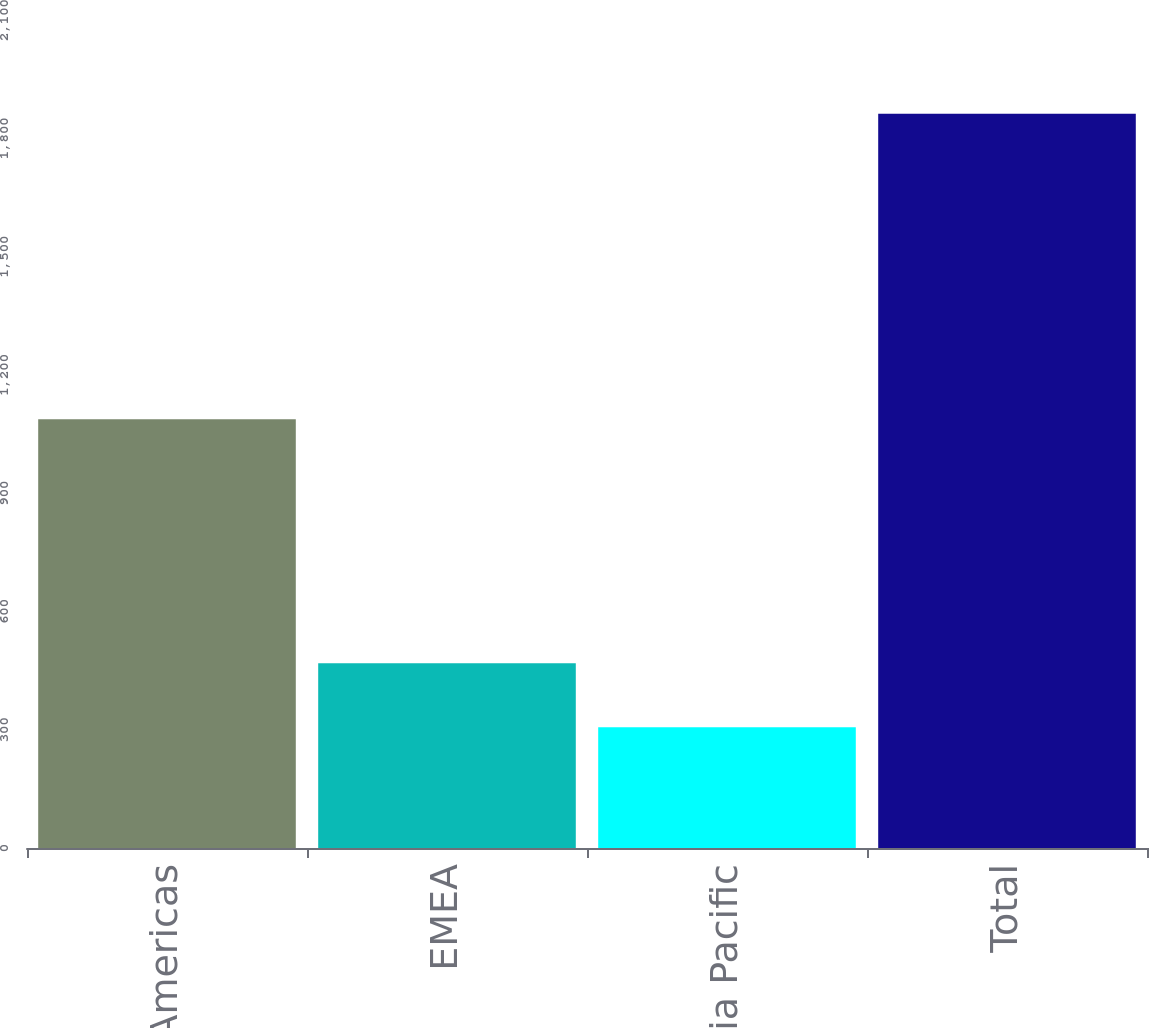Convert chart to OTSL. <chart><loc_0><loc_0><loc_500><loc_500><bar_chart><fcel>Americas<fcel>EMEA<fcel>Asia Pacific<fcel>Total<nl><fcel>1087.5<fcel>468.4<fcel>306.3<fcel>1862.2<nl></chart> 